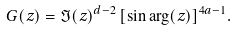Convert formula to latex. <formula><loc_0><loc_0><loc_500><loc_500>G ( z ) = \Im ( z ) ^ { d - 2 } \, [ \sin \arg ( z ) ] ^ { 4 a - 1 } .</formula> 